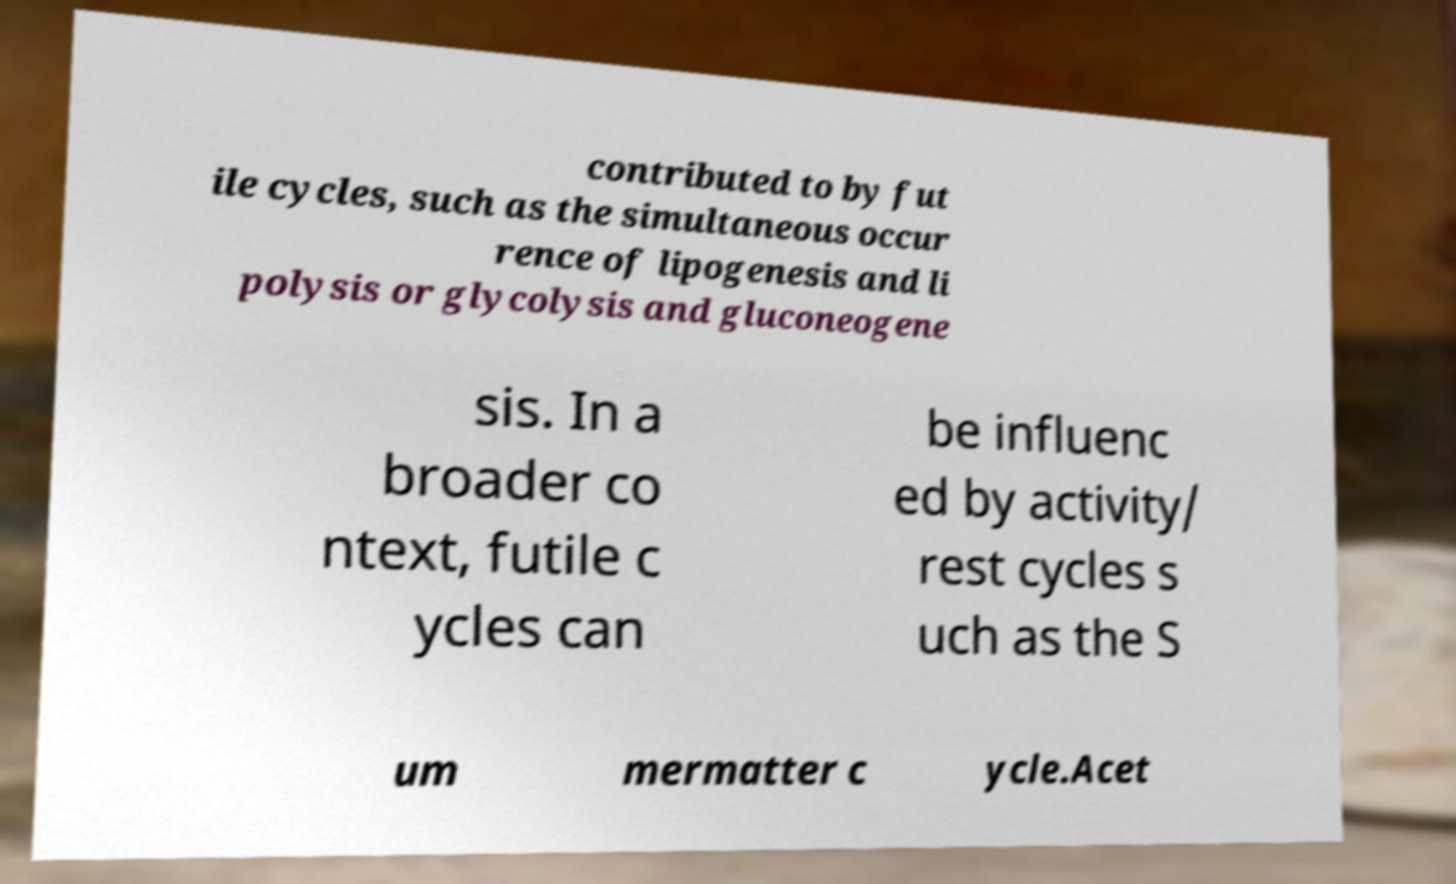Please read and relay the text visible in this image. What does it say? contributed to by fut ile cycles, such as the simultaneous occur rence of lipogenesis and li polysis or glycolysis and gluconeogene sis. In a broader co ntext, futile c ycles can be influenc ed by activity/ rest cycles s uch as the S um mermatter c ycle.Acet 